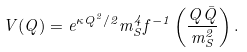Convert formula to latex. <formula><loc_0><loc_0><loc_500><loc_500>V ( Q ) = e ^ { \kappa Q ^ { 2 } / 2 } m _ { S } ^ { 4 } f ^ { - 1 } \left ( \frac { Q \bar { Q } } { m _ { S } ^ { 2 } } \right ) .</formula> 